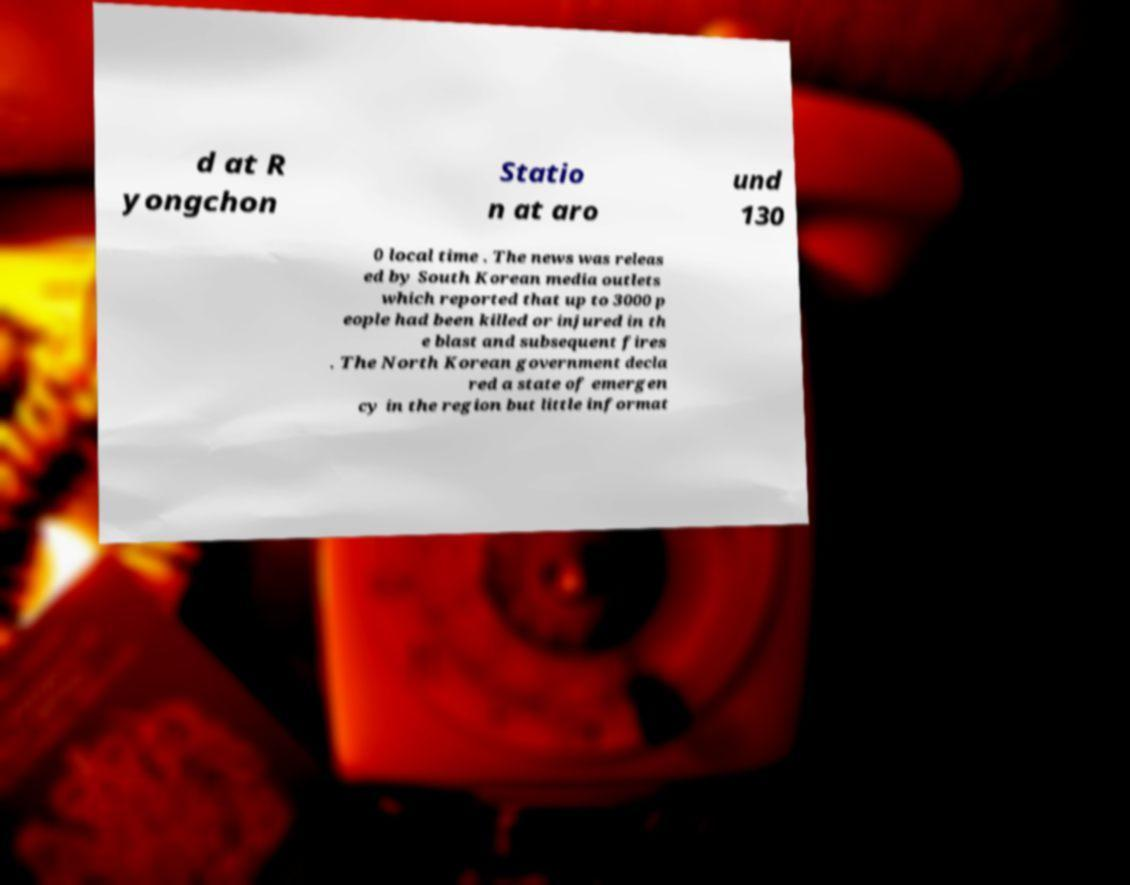Can you accurately transcribe the text from the provided image for me? d at R yongchon Statio n at aro und 130 0 local time . The news was releas ed by South Korean media outlets which reported that up to 3000 p eople had been killed or injured in th e blast and subsequent fires . The North Korean government decla red a state of emergen cy in the region but little informat 